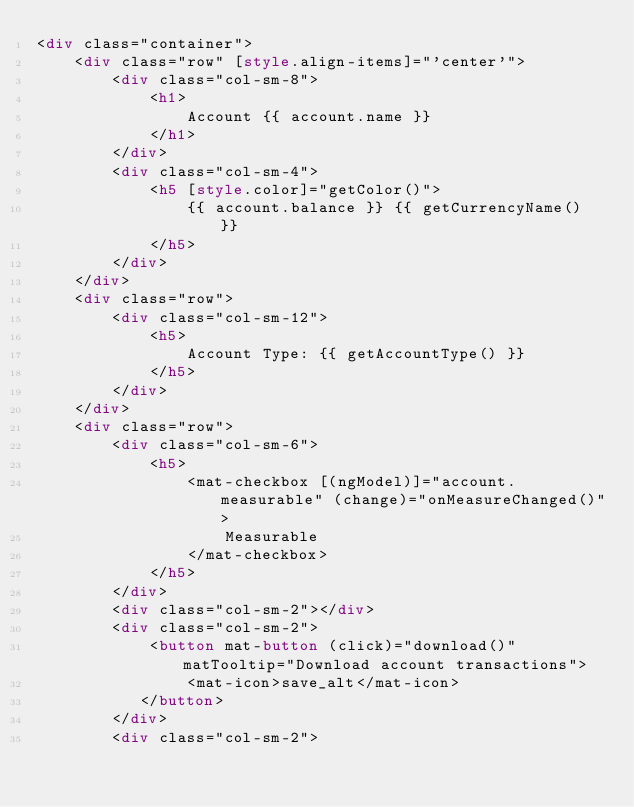Convert code to text. <code><loc_0><loc_0><loc_500><loc_500><_HTML_><div class="container">
    <div class="row" [style.align-items]="'center'">
        <div class="col-sm-8">
            <h1>
                Account {{ account.name }}
            </h1>
        </div>
        <div class="col-sm-4">
            <h5 [style.color]="getColor()">
                {{ account.balance }} {{ getCurrencyName() }}
            </h5>
        </div>
    </div>
    <div class="row">
        <div class="col-sm-12">
            <h5>
                Account Type: {{ getAccountType() }}
            </h5>
        </div>
    </div>
    <div class="row">
        <div class="col-sm-6">
            <h5>
                <mat-checkbox [(ngModel)]="account.measurable" (change)="onMeasureChanged()">
                    Measurable
                </mat-checkbox>
            </h5>
        </div>
        <div class="col-sm-2"></div>
        <div class="col-sm-2">
            <button mat-button (click)="download()" matTooltip="Download account transactions">
                <mat-icon>save_alt</mat-icon>
           </button>
        </div>
        <div class="col-sm-2"></code> 